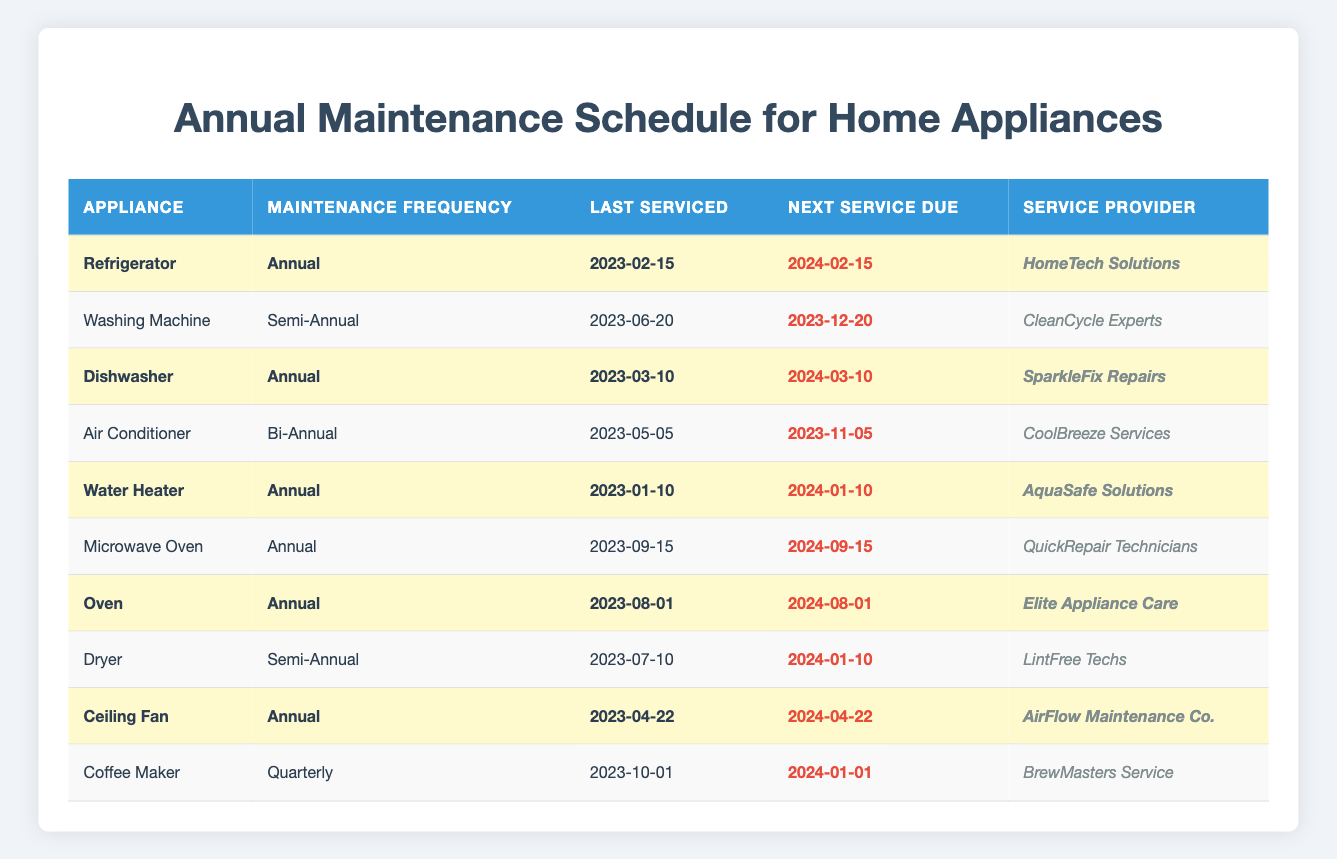What is the maintenance frequency for the Dishwasher? The table lists the Dishwasher under the appliance column, and its corresponding maintenance frequency is shown as "Annual."
Answer: Annual When is the next service due for the Refrigerator? The next service due date for the Refrigerator is found in the "Next Service Due" column, which states "2024-02-15."
Answer: 2024-02-15 Is the Microwave Oven scheduled for maintenance more frequently than the Dryer? The Microwave Oven has an annual maintenance frequency, while the Dryer has a semi-annual frequency. Thus, the Microwave Oven is not scheduled for maintenance more frequently than the Dryer.
Answer: No Which appliances are due for maintenance in 2024? Checking the "Next Service Due" column reveals the following appliances due in 2024: Refrigerator, Dishwasher, Water Heater, Oven, Ceiling Fan, and Microwave Oven.
Answer: 6 appliances What is the next maintenance date for appliances serviced in January? The Water Heater and the next service date for it is 2024-01-10. The next maintenance of the Dishwasher is 2024-03-10.
Answer: 2024-01-10 Which appliance has not been highlighted in the table? By reviewing the highlighted values column, the Washing Machine, Air Conditioner, Microwave Oven, and Dryer are not highlighted.
Answer: 4 appliances How many appliances are maintained bi-annually? In the table, only the Air Conditioner lists a maintenance frequency of "Bi-Annual." Therefore, there is only one appliance with this frequency.
Answer: 1 What is the latest last serviced date among all appliances? Scanning the "Last Serviced" dates, the latest date is "2023-09-15," which corresponds to the Microwave Oven.
Answer: 2023-09-15 Are there more appliances with annual maintenance than semi-annual maintenance? There are 6 appliances with annual maintenance (Refrigerator, Dishwasher, Water Heater, Oven, Ceiling Fan, Microwave Oven) and 2 appliances with semi-annual maintenance (Washing Machine, Dryer). Since 6 is greater than 2, there are indeed more.
Answer: Yes What is the average time between maintenance for appliances serviced annually? Calculate the time between maintenance for each annual appliance: Refrigerator (12 months), Dishwasher (12 months), Water Heater (12 months), Oven (12 months), and Ceiling Fan (12 months). The average is (12+12+12+12+12)/5 = 12 months.
Answer: 12 months Which service provider is assigned to the Ceiling Fan? Referring to the "Service Provider" column for the Ceiling Fan, it is listed as "AirFlow Maintenance Co."
Answer: AirFlow Maintenance Co 